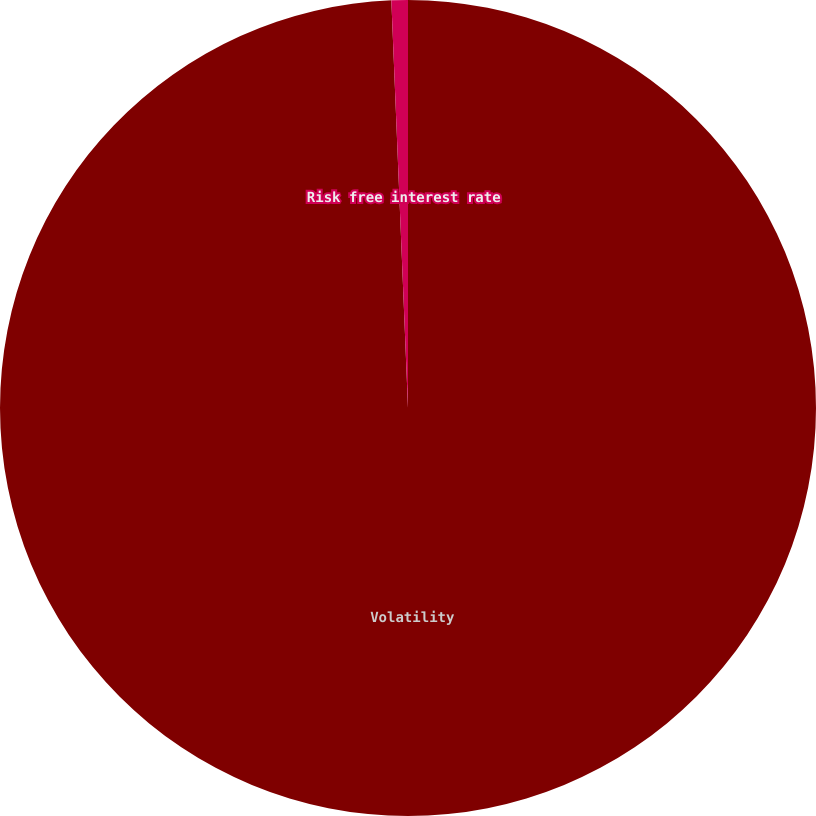<chart> <loc_0><loc_0><loc_500><loc_500><pie_chart><fcel>Volatility<fcel>Risk free interest rate<nl><fcel>99.35%<fcel>0.65%<nl></chart> 